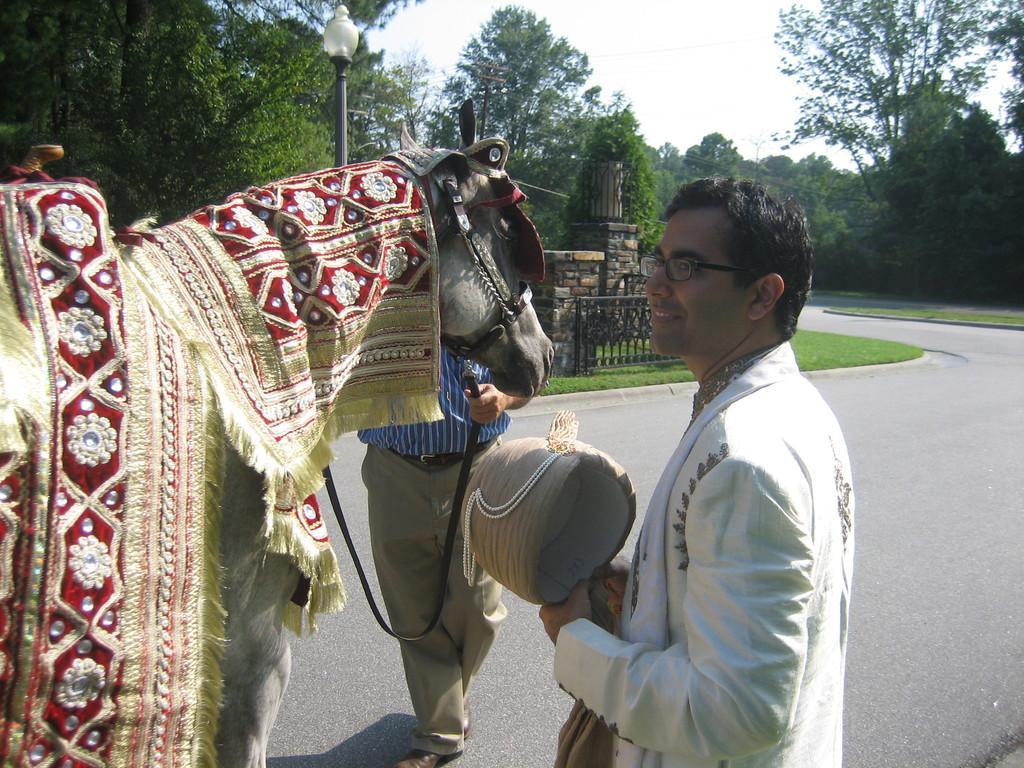How would you summarize this image in a sentence or two? In the image there is a man stood beside a horse and it was on the road and on the other sides of the roads there are trees and above its sky. 